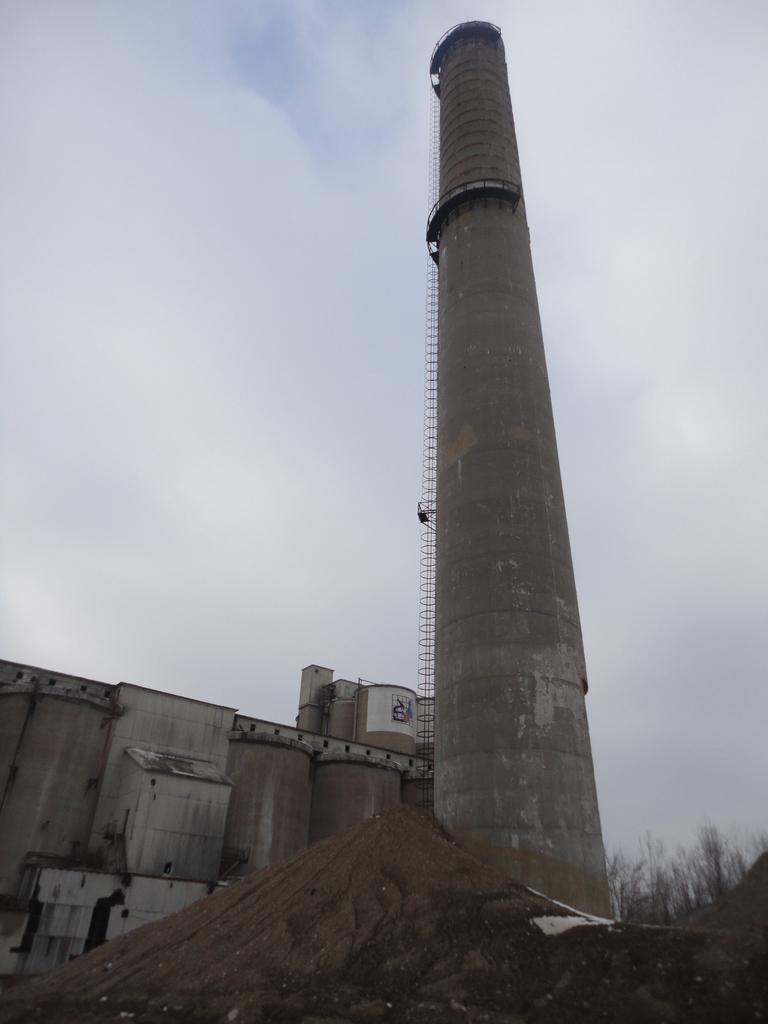What type of structure is present in the image? There is a building in the image. What feature can be seen on top of the building? There is a chimney in the image. What type of vegetation is visible in the image? There are trees in the image. What type of terrain is visible in the front of the image? There is sand visible in the front of the image. What can be seen in the background of the image? There are clouds and the sky visible in the background of the image. How many people are receiving treatment for their wounds in the image? There is no indication of any wounds or people receiving treatment in the image. 